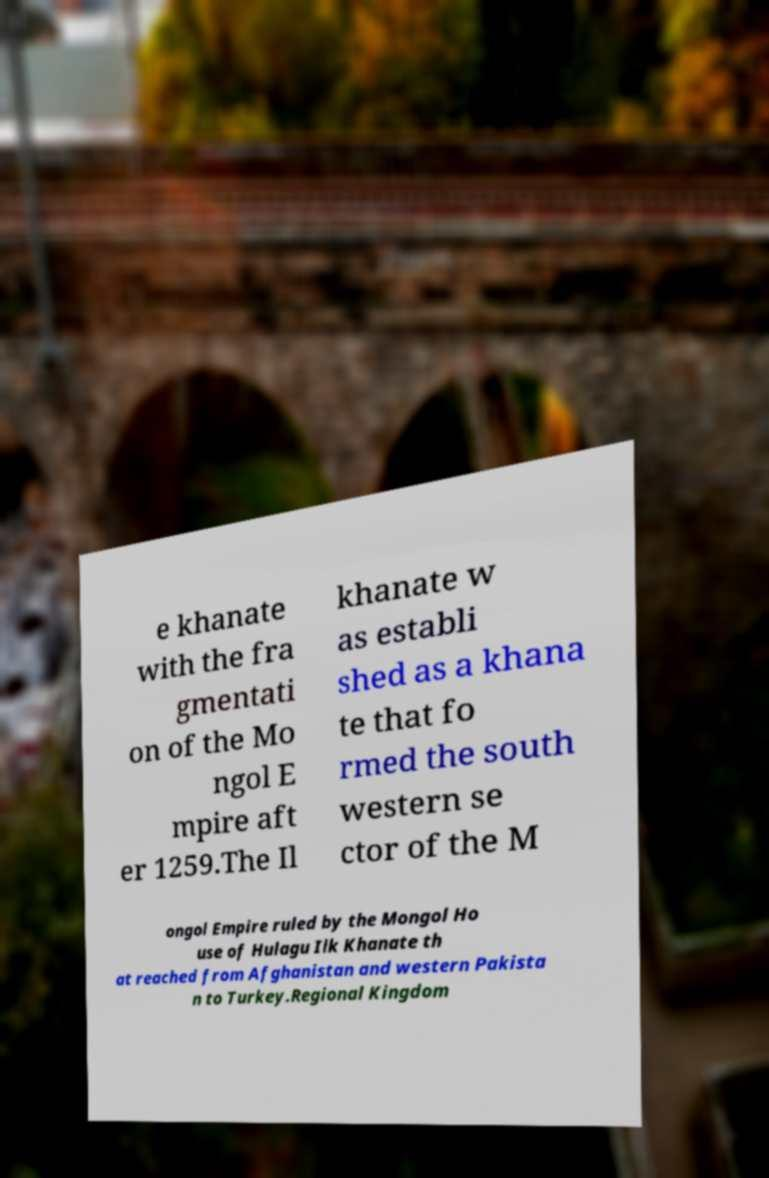What messages or text are displayed in this image? I need them in a readable, typed format. e khanate with the fra gmentati on of the Mo ngol E mpire aft er 1259.The Il khanate w as establi shed as a khana te that fo rmed the south western se ctor of the M ongol Empire ruled by the Mongol Ho use of Hulagu Ilk Khanate th at reached from Afghanistan and western Pakista n to Turkey.Regional Kingdom 